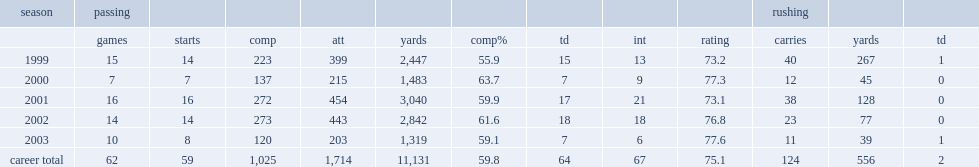How many yards did tim couch finish the 2002 season with? 2842.0. How many touchdowns did tim couch finish the 2002 season with? 18.0. 